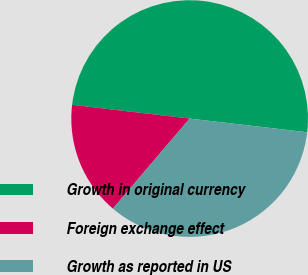Convert chart. <chart><loc_0><loc_0><loc_500><loc_500><pie_chart><fcel>Growth in original currency<fcel>Foreign exchange effect<fcel>Growth as reported in US<nl><fcel>50.0%<fcel>15.62%<fcel>34.38%<nl></chart> 